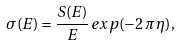<formula> <loc_0><loc_0><loc_500><loc_500>\sigma ( E ) = \frac { S ( E ) } { E } \, { e x p ( - 2 \, \pi \, \eta ) } ,</formula> 